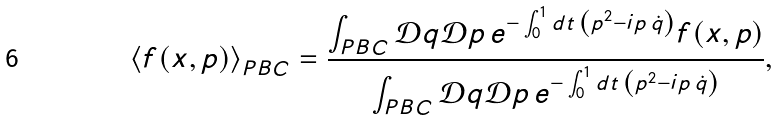Convert formula to latex. <formula><loc_0><loc_0><loc_500><loc_500>\left \langle f ( x , p ) \right \rangle _ { P B C } = \frac { \int _ { P B C } \mathcal { D } q \mathcal { D } p \, e ^ { - \int _ { 0 } ^ { 1 } d t \, \left ( p ^ { 2 } - i p \, \dot { q } \right ) } f ( x , p ) } { \int _ { P B C } \mathcal { D } q \mathcal { D } p \, e ^ { - \int _ { 0 } ^ { 1 } d t \, \left ( p ^ { 2 } - i p \, \dot { q } \right ) } } ,</formula> 